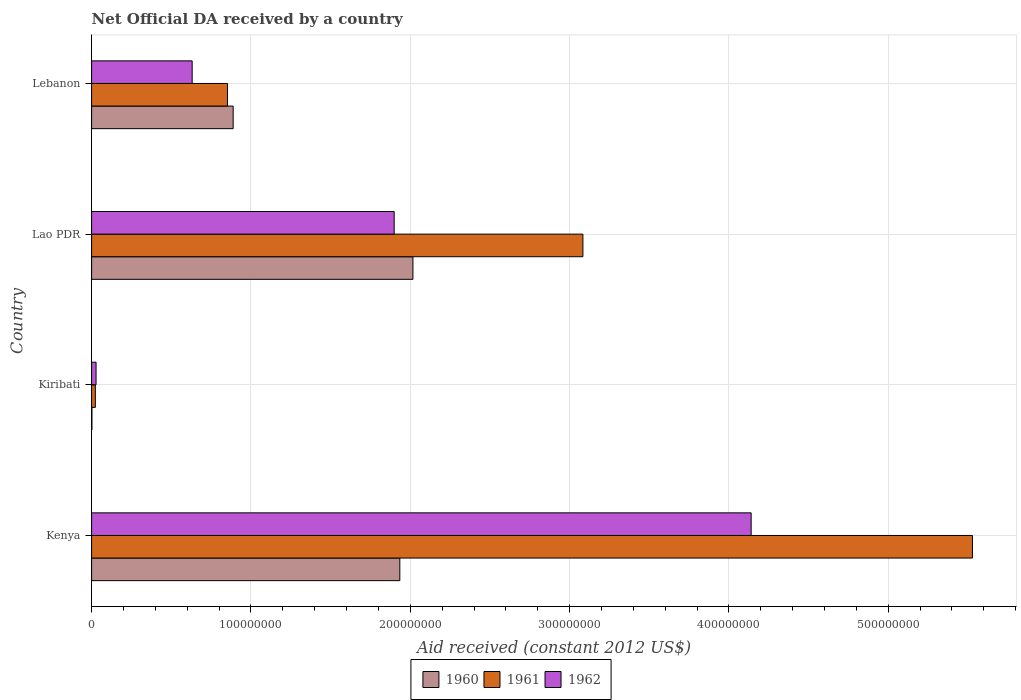Are the number of bars per tick equal to the number of legend labels?
Offer a terse response. Yes. Are the number of bars on each tick of the Y-axis equal?
Your answer should be compact. Yes. What is the label of the 3rd group of bars from the top?
Keep it short and to the point. Kiribati. What is the net official development assistance aid received in 1961 in Lao PDR?
Keep it short and to the point. 3.08e+08. Across all countries, what is the maximum net official development assistance aid received in 1962?
Your answer should be compact. 4.14e+08. Across all countries, what is the minimum net official development assistance aid received in 1962?
Your response must be concise. 2.80e+06. In which country was the net official development assistance aid received in 1960 maximum?
Keep it short and to the point. Lao PDR. In which country was the net official development assistance aid received in 1962 minimum?
Your answer should be compact. Kiribati. What is the total net official development assistance aid received in 1960 in the graph?
Your answer should be compact. 4.84e+08. What is the difference between the net official development assistance aid received in 1960 in Kenya and that in Kiribati?
Offer a terse response. 1.93e+08. What is the difference between the net official development assistance aid received in 1960 in Lebanon and the net official development assistance aid received in 1961 in Kenya?
Offer a very short reply. -4.64e+08. What is the average net official development assistance aid received in 1962 per country?
Ensure brevity in your answer.  1.67e+08. What is the difference between the net official development assistance aid received in 1960 and net official development assistance aid received in 1961 in Kiribati?
Your response must be concise. -2.16e+06. In how many countries, is the net official development assistance aid received in 1962 greater than 480000000 US$?
Make the answer very short. 0. What is the ratio of the net official development assistance aid received in 1960 in Kenya to that in Kiribati?
Keep it short and to the point. 1018.16. What is the difference between the highest and the second highest net official development assistance aid received in 1962?
Your response must be concise. 2.24e+08. What is the difference between the highest and the lowest net official development assistance aid received in 1960?
Offer a very short reply. 2.01e+08. In how many countries, is the net official development assistance aid received in 1960 greater than the average net official development assistance aid received in 1960 taken over all countries?
Your answer should be compact. 2. Is the sum of the net official development assistance aid received in 1960 in Kiribati and Lebanon greater than the maximum net official development assistance aid received in 1962 across all countries?
Your answer should be compact. No. What does the 3rd bar from the top in Kenya represents?
Make the answer very short. 1960. What does the 2nd bar from the bottom in Lao PDR represents?
Give a very brief answer. 1961. Are all the bars in the graph horizontal?
Your answer should be compact. Yes. What is the difference between two consecutive major ticks on the X-axis?
Make the answer very short. 1.00e+08. Does the graph contain grids?
Your answer should be compact. Yes. How many legend labels are there?
Provide a short and direct response. 3. How are the legend labels stacked?
Your answer should be very brief. Horizontal. What is the title of the graph?
Ensure brevity in your answer.  Net Official DA received by a country. Does "1969" appear as one of the legend labels in the graph?
Ensure brevity in your answer.  No. What is the label or title of the X-axis?
Offer a terse response. Aid received (constant 2012 US$). What is the Aid received (constant 2012 US$) in 1960 in Kenya?
Provide a succinct answer. 1.93e+08. What is the Aid received (constant 2012 US$) of 1961 in Kenya?
Keep it short and to the point. 5.53e+08. What is the Aid received (constant 2012 US$) of 1962 in Kenya?
Keep it short and to the point. 4.14e+08. What is the Aid received (constant 2012 US$) in 1960 in Kiribati?
Offer a very short reply. 1.90e+05. What is the Aid received (constant 2012 US$) of 1961 in Kiribati?
Provide a short and direct response. 2.35e+06. What is the Aid received (constant 2012 US$) in 1962 in Kiribati?
Your answer should be very brief. 2.80e+06. What is the Aid received (constant 2012 US$) of 1960 in Lao PDR?
Keep it short and to the point. 2.02e+08. What is the Aid received (constant 2012 US$) of 1961 in Lao PDR?
Provide a succinct answer. 3.08e+08. What is the Aid received (constant 2012 US$) of 1962 in Lao PDR?
Offer a very short reply. 1.90e+08. What is the Aid received (constant 2012 US$) of 1960 in Lebanon?
Offer a very short reply. 8.88e+07. What is the Aid received (constant 2012 US$) of 1961 in Lebanon?
Your response must be concise. 8.53e+07. What is the Aid received (constant 2012 US$) of 1962 in Lebanon?
Provide a succinct answer. 6.31e+07. Across all countries, what is the maximum Aid received (constant 2012 US$) in 1960?
Ensure brevity in your answer.  2.02e+08. Across all countries, what is the maximum Aid received (constant 2012 US$) of 1961?
Your response must be concise. 5.53e+08. Across all countries, what is the maximum Aid received (constant 2012 US$) of 1962?
Offer a very short reply. 4.14e+08. Across all countries, what is the minimum Aid received (constant 2012 US$) in 1960?
Your response must be concise. 1.90e+05. Across all countries, what is the minimum Aid received (constant 2012 US$) in 1961?
Give a very brief answer. 2.35e+06. Across all countries, what is the minimum Aid received (constant 2012 US$) of 1962?
Give a very brief answer. 2.80e+06. What is the total Aid received (constant 2012 US$) in 1960 in the graph?
Your answer should be compact. 4.84e+08. What is the total Aid received (constant 2012 US$) in 1961 in the graph?
Give a very brief answer. 9.49e+08. What is the total Aid received (constant 2012 US$) of 1962 in the graph?
Offer a very short reply. 6.70e+08. What is the difference between the Aid received (constant 2012 US$) in 1960 in Kenya and that in Kiribati?
Your answer should be compact. 1.93e+08. What is the difference between the Aid received (constant 2012 US$) in 1961 in Kenya and that in Kiribati?
Your answer should be very brief. 5.50e+08. What is the difference between the Aid received (constant 2012 US$) of 1962 in Kenya and that in Kiribati?
Your response must be concise. 4.11e+08. What is the difference between the Aid received (constant 2012 US$) of 1960 in Kenya and that in Lao PDR?
Your response must be concise. -8.23e+06. What is the difference between the Aid received (constant 2012 US$) in 1961 in Kenya and that in Lao PDR?
Your response must be concise. 2.44e+08. What is the difference between the Aid received (constant 2012 US$) of 1962 in Kenya and that in Lao PDR?
Keep it short and to the point. 2.24e+08. What is the difference between the Aid received (constant 2012 US$) in 1960 in Kenya and that in Lebanon?
Make the answer very short. 1.05e+08. What is the difference between the Aid received (constant 2012 US$) of 1961 in Kenya and that in Lebanon?
Make the answer very short. 4.68e+08. What is the difference between the Aid received (constant 2012 US$) in 1962 in Kenya and that in Lebanon?
Offer a terse response. 3.51e+08. What is the difference between the Aid received (constant 2012 US$) of 1960 in Kiribati and that in Lao PDR?
Provide a succinct answer. -2.01e+08. What is the difference between the Aid received (constant 2012 US$) in 1961 in Kiribati and that in Lao PDR?
Give a very brief answer. -3.06e+08. What is the difference between the Aid received (constant 2012 US$) of 1962 in Kiribati and that in Lao PDR?
Make the answer very short. -1.87e+08. What is the difference between the Aid received (constant 2012 US$) of 1960 in Kiribati and that in Lebanon?
Offer a terse response. -8.87e+07. What is the difference between the Aid received (constant 2012 US$) in 1961 in Kiribati and that in Lebanon?
Give a very brief answer. -8.29e+07. What is the difference between the Aid received (constant 2012 US$) in 1962 in Kiribati and that in Lebanon?
Offer a very short reply. -6.03e+07. What is the difference between the Aid received (constant 2012 US$) of 1960 in Lao PDR and that in Lebanon?
Your response must be concise. 1.13e+08. What is the difference between the Aid received (constant 2012 US$) in 1961 in Lao PDR and that in Lebanon?
Give a very brief answer. 2.23e+08. What is the difference between the Aid received (constant 2012 US$) in 1962 in Lao PDR and that in Lebanon?
Provide a short and direct response. 1.27e+08. What is the difference between the Aid received (constant 2012 US$) of 1960 in Kenya and the Aid received (constant 2012 US$) of 1961 in Kiribati?
Keep it short and to the point. 1.91e+08. What is the difference between the Aid received (constant 2012 US$) of 1960 in Kenya and the Aid received (constant 2012 US$) of 1962 in Kiribati?
Ensure brevity in your answer.  1.91e+08. What is the difference between the Aid received (constant 2012 US$) of 1961 in Kenya and the Aid received (constant 2012 US$) of 1962 in Kiribati?
Provide a succinct answer. 5.50e+08. What is the difference between the Aid received (constant 2012 US$) in 1960 in Kenya and the Aid received (constant 2012 US$) in 1961 in Lao PDR?
Your response must be concise. -1.15e+08. What is the difference between the Aid received (constant 2012 US$) of 1960 in Kenya and the Aid received (constant 2012 US$) of 1962 in Lao PDR?
Provide a succinct answer. 3.54e+06. What is the difference between the Aid received (constant 2012 US$) of 1961 in Kenya and the Aid received (constant 2012 US$) of 1962 in Lao PDR?
Offer a very short reply. 3.63e+08. What is the difference between the Aid received (constant 2012 US$) of 1960 in Kenya and the Aid received (constant 2012 US$) of 1961 in Lebanon?
Offer a terse response. 1.08e+08. What is the difference between the Aid received (constant 2012 US$) in 1960 in Kenya and the Aid received (constant 2012 US$) in 1962 in Lebanon?
Provide a short and direct response. 1.30e+08. What is the difference between the Aid received (constant 2012 US$) of 1961 in Kenya and the Aid received (constant 2012 US$) of 1962 in Lebanon?
Provide a succinct answer. 4.90e+08. What is the difference between the Aid received (constant 2012 US$) of 1960 in Kiribati and the Aid received (constant 2012 US$) of 1961 in Lao PDR?
Your response must be concise. -3.08e+08. What is the difference between the Aid received (constant 2012 US$) of 1960 in Kiribati and the Aid received (constant 2012 US$) of 1962 in Lao PDR?
Offer a very short reply. -1.90e+08. What is the difference between the Aid received (constant 2012 US$) in 1961 in Kiribati and the Aid received (constant 2012 US$) in 1962 in Lao PDR?
Your answer should be very brief. -1.88e+08. What is the difference between the Aid received (constant 2012 US$) in 1960 in Kiribati and the Aid received (constant 2012 US$) in 1961 in Lebanon?
Your answer should be very brief. -8.51e+07. What is the difference between the Aid received (constant 2012 US$) in 1960 in Kiribati and the Aid received (constant 2012 US$) in 1962 in Lebanon?
Keep it short and to the point. -6.29e+07. What is the difference between the Aid received (constant 2012 US$) in 1961 in Kiribati and the Aid received (constant 2012 US$) in 1962 in Lebanon?
Give a very brief answer. -6.08e+07. What is the difference between the Aid received (constant 2012 US$) in 1960 in Lao PDR and the Aid received (constant 2012 US$) in 1961 in Lebanon?
Your answer should be very brief. 1.16e+08. What is the difference between the Aid received (constant 2012 US$) of 1960 in Lao PDR and the Aid received (constant 2012 US$) of 1962 in Lebanon?
Ensure brevity in your answer.  1.39e+08. What is the difference between the Aid received (constant 2012 US$) of 1961 in Lao PDR and the Aid received (constant 2012 US$) of 1962 in Lebanon?
Your answer should be compact. 2.45e+08. What is the average Aid received (constant 2012 US$) in 1960 per country?
Provide a short and direct response. 1.21e+08. What is the average Aid received (constant 2012 US$) in 1961 per country?
Give a very brief answer. 2.37e+08. What is the average Aid received (constant 2012 US$) of 1962 per country?
Make the answer very short. 1.67e+08. What is the difference between the Aid received (constant 2012 US$) of 1960 and Aid received (constant 2012 US$) of 1961 in Kenya?
Ensure brevity in your answer.  -3.59e+08. What is the difference between the Aid received (constant 2012 US$) of 1960 and Aid received (constant 2012 US$) of 1962 in Kenya?
Your answer should be very brief. -2.20e+08. What is the difference between the Aid received (constant 2012 US$) in 1961 and Aid received (constant 2012 US$) in 1962 in Kenya?
Your answer should be compact. 1.39e+08. What is the difference between the Aid received (constant 2012 US$) of 1960 and Aid received (constant 2012 US$) of 1961 in Kiribati?
Your answer should be compact. -2.16e+06. What is the difference between the Aid received (constant 2012 US$) in 1960 and Aid received (constant 2012 US$) in 1962 in Kiribati?
Offer a very short reply. -2.61e+06. What is the difference between the Aid received (constant 2012 US$) in 1961 and Aid received (constant 2012 US$) in 1962 in Kiribati?
Give a very brief answer. -4.50e+05. What is the difference between the Aid received (constant 2012 US$) of 1960 and Aid received (constant 2012 US$) of 1961 in Lao PDR?
Make the answer very short. -1.07e+08. What is the difference between the Aid received (constant 2012 US$) in 1960 and Aid received (constant 2012 US$) in 1962 in Lao PDR?
Offer a terse response. 1.18e+07. What is the difference between the Aid received (constant 2012 US$) of 1961 and Aid received (constant 2012 US$) of 1962 in Lao PDR?
Offer a terse response. 1.18e+08. What is the difference between the Aid received (constant 2012 US$) of 1960 and Aid received (constant 2012 US$) of 1961 in Lebanon?
Provide a short and direct response. 3.57e+06. What is the difference between the Aid received (constant 2012 US$) of 1960 and Aid received (constant 2012 US$) of 1962 in Lebanon?
Your answer should be compact. 2.57e+07. What is the difference between the Aid received (constant 2012 US$) of 1961 and Aid received (constant 2012 US$) of 1962 in Lebanon?
Provide a short and direct response. 2.22e+07. What is the ratio of the Aid received (constant 2012 US$) of 1960 in Kenya to that in Kiribati?
Offer a terse response. 1018.16. What is the ratio of the Aid received (constant 2012 US$) in 1961 in Kenya to that in Kiribati?
Offer a very short reply. 235.25. What is the ratio of the Aid received (constant 2012 US$) of 1962 in Kenya to that in Kiribati?
Your answer should be compact. 147.84. What is the ratio of the Aid received (constant 2012 US$) of 1960 in Kenya to that in Lao PDR?
Offer a very short reply. 0.96. What is the ratio of the Aid received (constant 2012 US$) in 1961 in Kenya to that in Lao PDR?
Keep it short and to the point. 1.79. What is the ratio of the Aid received (constant 2012 US$) in 1962 in Kenya to that in Lao PDR?
Offer a very short reply. 2.18. What is the ratio of the Aid received (constant 2012 US$) of 1960 in Kenya to that in Lebanon?
Provide a succinct answer. 2.18. What is the ratio of the Aid received (constant 2012 US$) of 1961 in Kenya to that in Lebanon?
Ensure brevity in your answer.  6.48. What is the ratio of the Aid received (constant 2012 US$) of 1962 in Kenya to that in Lebanon?
Ensure brevity in your answer.  6.56. What is the ratio of the Aid received (constant 2012 US$) in 1960 in Kiribati to that in Lao PDR?
Keep it short and to the point. 0. What is the ratio of the Aid received (constant 2012 US$) of 1961 in Kiribati to that in Lao PDR?
Provide a succinct answer. 0.01. What is the ratio of the Aid received (constant 2012 US$) in 1962 in Kiribati to that in Lao PDR?
Your answer should be very brief. 0.01. What is the ratio of the Aid received (constant 2012 US$) in 1960 in Kiribati to that in Lebanon?
Your response must be concise. 0. What is the ratio of the Aid received (constant 2012 US$) of 1961 in Kiribati to that in Lebanon?
Keep it short and to the point. 0.03. What is the ratio of the Aid received (constant 2012 US$) of 1962 in Kiribati to that in Lebanon?
Provide a short and direct response. 0.04. What is the ratio of the Aid received (constant 2012 US$) in 1960 in Lao PDR to that in Lebanon?
Offer a very short reply. 2.27. What is the ratio of the Aid received (constant 2012 US$) in 1961 in Lao PDR to that in Lebanon?
Offer a terse response. 3.62. What is the ratio of the Aid received (constant 2012 US$) of 1962 in Lao PDR to that in Lebanon?
Give a very brief answer. 3.01. What is the difference between the highest and the second highest Aid received (constant 2012 US$) in 1960?
Ensure brevity in your answer.  8.23e+06. What is the difference between the highest and the second highest Aid received (constant 2012 US$) of 1961?
Your answer should be compact. 2.44e+08. What is the difference between the highest and the second highest Aid received (constant 2012 US$) of 1962?
Ensure brevity in your answer.  2.24e+08. What is the difference between the highest and the lowest Aid received (constant 2012 US$) of 1960?
Your answer should be compact. 2.01e+08. What is the difference between the highest and the lowest Aid received (constant 2012 US$) in 1961?
Your answer should be compact. 5.50e+08. What is the difference between the highest and the lowest Aid received (constant 2012 US$) in 1962?
Offer a very short reply. 4.11e+08. 